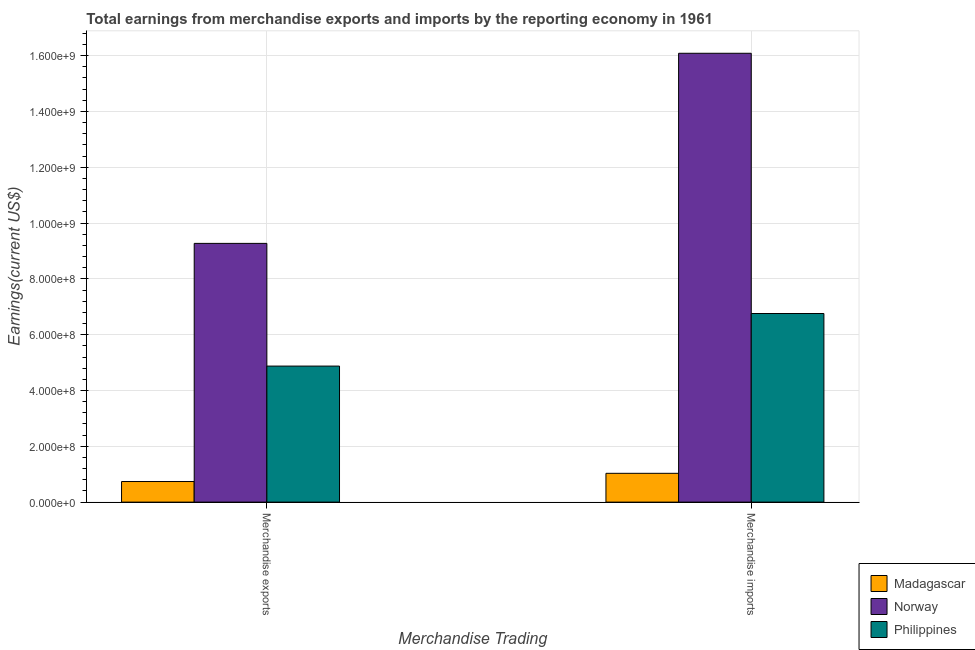How many groups of bars are there?
Your answer should be compact. 2. How many bars are there on the 2nd tick from the left?
Provide a short and direct response. 3. What is the label of the 1st group of bars from the left?
Your answer should be very brief. Merchandise exports. What is the earnings from merchandise imports in Madagascar?
Make the answer very short. 1.03e+08. Across all countries, what is the maximum earnings from merchandise exports?
Your response must be concise. 9.27e+08. Across all countries, what is the minimum earnings from merchandise exports?
Provide a succinct answer. 7.38e+07. In which country was the earnings from merchandise imports minimum?
Provide a succinct answer. Madagascar. What is the total earnings from merchandise imports in the graph?
Your answer should be compact. 2.39e+09. What is the difference between the earnings from merchandise imports in Philippines and that in Norway?
Ensure brevity in your answer.  -9.33e+08. What is the difference between the earnings from merchandise exports in Madagascar and the earnings from merchandise imports in Philippines?
Your answer should be compact. -6.02e+08. What is the average earnings from merchandise imports per country?
Ensure brevity in your answer.  7.96e+08. What is the difference between the earnings from merchandise exports and earnings from merchandise imports in Madagascar?
Your answer should be very brief. -2.94e+07. In how many countries, is the earnings from merchandise exports greater than 760000000 US$?
Offer a terse response. 1. What is the ratio of the earnings from merchandise imports in Madagascar to that in Norway?
Ensure brevity in your answer.  0.06. Is the earnings from merchandise exports in Norway less than that in Madagascar?
Provide a short and direct response. No. In how many countries, is the earnings from merchandise imports greater than the average earnings from merchandise imports taken over all countries?
Provide a succinct answer. 1. What does the 3rd bar from the left in Merchandise exports represents?
Provide a short and direct response. Philippines. What does the 1st bar from the right in Merchandise exports represents?
Provide a succinct answer. Philippines. How many bars are there?
Provide a short and direct response. 6. How many countries are there in the graph?
Your answer should be very brief. 3. What is the difference between two consecutive major ticks on the Y-axis?
Your response must be concise. 2.00e+08. Are the values on the major ticks of Y-axis written in scientific E-notation?
Offer a very short reply. Yes. Does the graph contain any zero values?
Ensure brevity in your answer.  No. Does the graph contain grids?
Your answer should be compact. Yes. Where does the legend appear in the graph?
Your answer should be compact. Bottom right. How many legend labels are there?
Make the answer very short. 3. How are the legend labels stacked?
Provide a short and direct response. Vertical. What is the title of the graph?
Provide a short and direct response. Total earnings from merchandise exports and imports by the reporting economy in 1961. What is the label or title of the X-axis?
Offer a very short reply. Merchandise Trading. What is the label or title of the Y-axis?
Ensure brevity in your answer.  Earnings(current US$). What is the Earnings(current US$) in Madagascar in Merchandise exports?
Offer a terse response. 7.38e+07. What is the Earnings(current US$) of Norway in Merchandise exports?
Provide a succinct answer. 9.27e+08. What is the Earnings(current US$) in Philippines in Merchandise exports?
Give a very brief answer. 4.88e+08. What is the Earnings(current US$) in Madagascar in Merchandise imports?
Provide a succinct answer. 1.03e+08. What is the Earnings(current US$) in Norway in Merchandise imports?
Keep it short and to the point. 1.61e+09. What is the Earnings(current US$) in Philippines in Merchandise imports?
Your response must be concise. 6.76e+08. Across all Merchandise Trading, what is the maximum Earnings(current US$) in Madagascar?
Your answer should be very brief. 1.03e+08. Across all Merchandise Trading, what is the maximum Earnings(current US$) of Norway?
Offer a terse response. 1.61e+09. Across all Merchandise Trading, what is the maximum Earnings(current US$) of Philippines?
Give a very brief answer. 6.76e+08. Across all Merchandise Trading, what is the minimum Earnings(current US$) in Madagascar?
Your answer should be very brief. 7.38e+07. Across all Merchandise Trading, what is the minimum Earnings(current US$) of Norway?
Your answer should be compact. 9.27e+08. Across all Merchandise Trading, what is the minimum Earnings(current US$) of Philippines?
Offer a terse response. 4.88e+08. What is the total Earnings(current US$) in Madagascar in the graph?
Provide a short and direct response. 1.77e+08. What is the total Earnings(current US$) in Norway in the graph?
Offer a terse response. 2.54e+09. What is the total Earnings(current US$) of Philippines in the graph?
Your answer should be very brief. 1.16e+09. What is the difference between the Earnings(current US$) in Madagascar in Merchandise exports and that in Merchandise imports?
Make the answer very short. -2.94e+07. What is the difference between the Earnings(current US$) in Norway in Merchandise exports and that in Merchandise imports?
Make the answer very short. -6.81e+08. What is the difference between the Earnings(current US$) in Philippines in Merchandise exports and that in Merchandise imports?
Your response must be concise. -1.88e+08. What is the difference between the Earnings(current US$) in Madagascar in Merchandise exports and the Earnings(current US$) in Norway in Merchandise imports?
Make the answer very short. -1.53e+09. What is the difference between the Earnings(current US$) in Madagascar in Merchandise exports and the Earnings(current US$) in Philippines in Merchandise imports?
Provide a succinct answer. -6.02e+08. What is the difference between the Earnings(current US$) of Norway in Merchandise exports and the Earnings(current US$) of Philippines in Merchandise imports?
Offer a very short reply. 2.51e+08. What is the average Earnings(current US$) in Madagascar per Merchandise Trading?
Keep it short and to the point. 8.85e+07. What is the average Earnings(current US$) in Norway per Merchandise Trading?
Provide a succinct answer. 1.27e+09. What is the average Earnings(current US$) of Philippines per Merchandise Trading?
Make the answer very short. 5.82e+08. What is the difference between the Earnings(current US$) in Madagascar and Earnings(current US$) in Norway in Merchandise exports?
Offer a very short reply. -8.53e+08. What is the difference between the Earnings(current US$) of Madagascar and Earnings(current US$) of Philippines in Merchandise exports?
Provide a succinct answer. -4.14e+08. What is the difference between the Earnings(current US$) in Norway and Earnings(current US$) in Philippines in Merchandise exports?
Provide a short and direct response. 4.40e+08. What is the difference between the Earnings(current US$) of Madagascar and Earnings(current US$) of Norway in Merchandise imports?
Offer a terse response. -1.51e+09. What is the difference between the Earnings(current US$) of Madagascar and Earnings(current US$) of Philippines in Merchandise imports?
Offer a terse response. -5.73e+08. What is the difference between the Earnings(current US$) in Norway and Earnings(current US$) in Philippines in Merchandise imports?
Give a very brief answer. 9.33e+08. What is the ratio of the Earnings(current US$) of Madagascar in Merchandise exports to that in Merchandise imports?
Give a very brief answer. 0.72. What is the ratio of the Earnings(current US$) of Norway in Merchandise exports to that in Merchandise imports?
Make the answer very short. 0.58. What is the ratio of the Earnings(current US$) of Philippines in Merchandise exports to that in Merchandise imports?
Offer a terse response. 0.72. What is the difference between the highest and the second highest Earnings(current US$) of Madagascar?
Your answer should be compact. 2.94e+07. What is the difference between the highest and the second highest Earnings(current US$) in Norway?
Give a very brief answer. 6.81e+08. What is the difference between the highest and the second highest Earnings(current US$) of Philippines?
Keep it short and to the point. 1.88e+08. What is the difference between the highest and the lowest Earnings(current US$) of Madagascar?
Your response must be concise. 2.94e+07. What is the difference between the highest and the lowest Earnings(current US$) in Norway?
Make the answer very short. 6.81e+08. What is the difference between the highest and the lowest Earnings(current US$) in Philippines?
Your answer should be compact. 1.88e+08. 